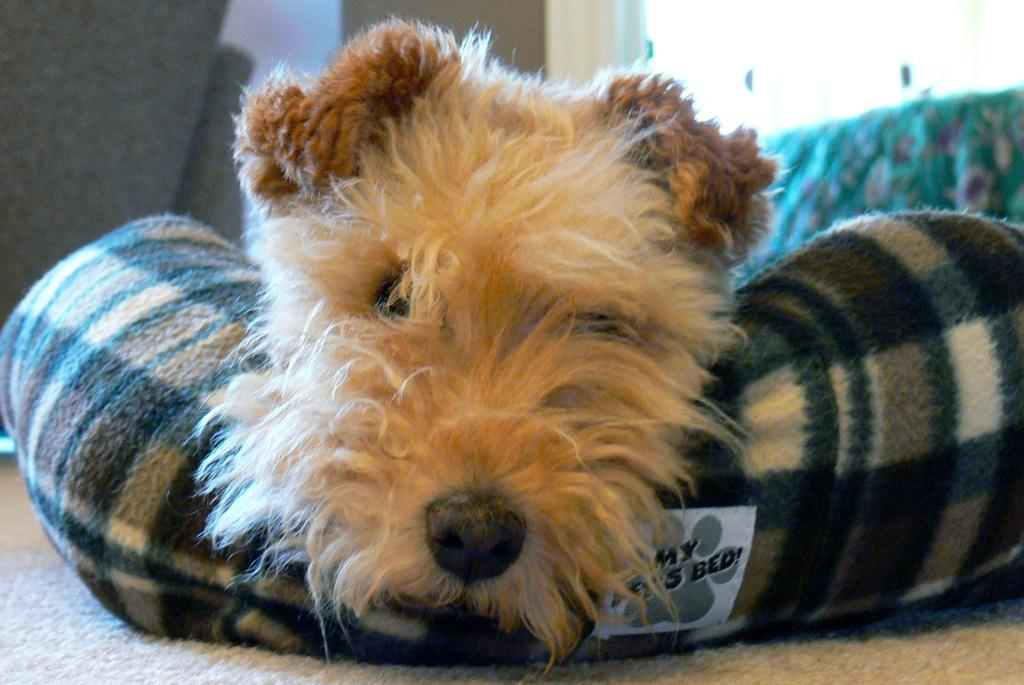What type of animal is present in the image? There is a dog in the image. Where is the dog located? The dog is on a bed. Where is the nest located in the image? There is no nest present in the image. What type of jar can be seen on the bed with the dog? There is no jar present in the image. 